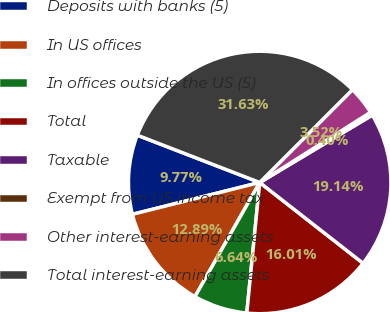Convert chart. <chart><loc_0><loc_0><loc_500><loc_500><pie_chart><fcel>Deposits with banks (5)<fcel>In US offices<fcel>In offices outside the US (5)<fcel>Total<fcel>Taxable<fcel>Exempt from US income tax<fcel>Other interest-earning assets<fcel>Total interest-earning assets<nl><fcel>9.77%<fcel>12.89%<fcel>6.64%<fcel>16.01%<fcel>19.14%<fcel>0.4%<fcel>3.52%<fcel>31.63%<nl></chart> 